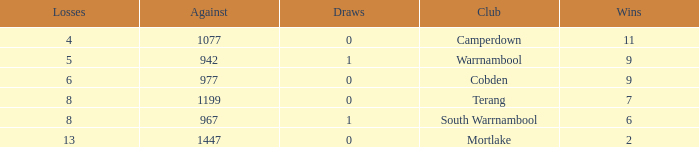How many draws did Mortlake have when the losses were more than 5? 1.0. 